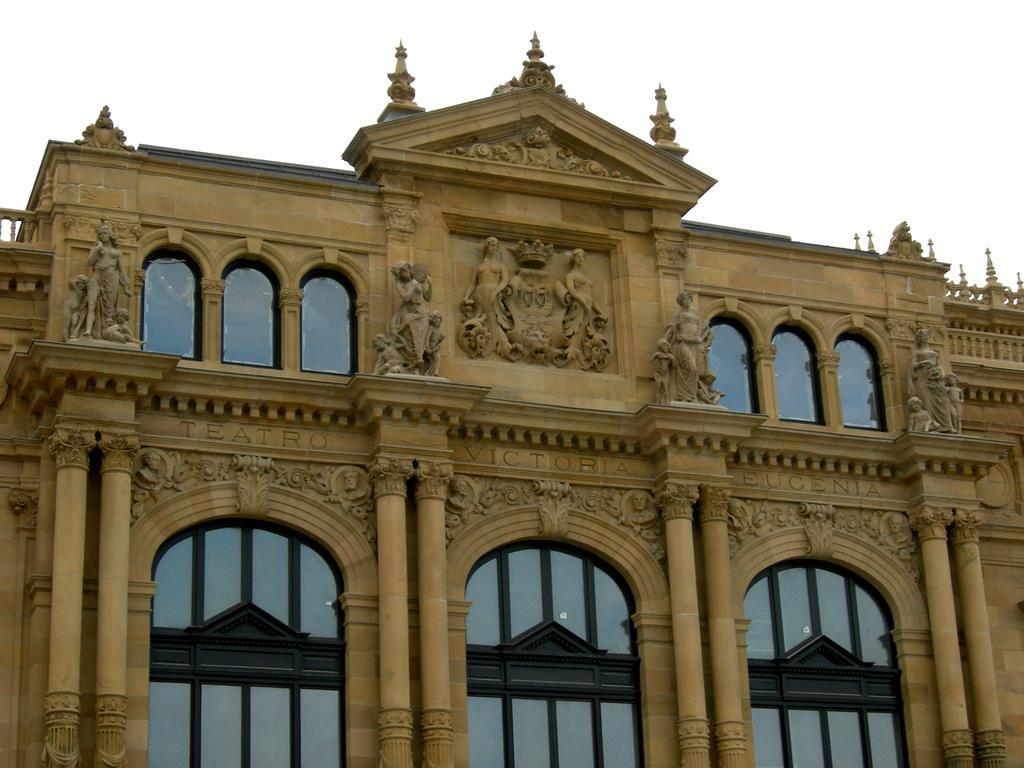Please provide a concise description of this image. In this image I can see the building which is in brown color. I can see the statues to the building. And there is a white background. 